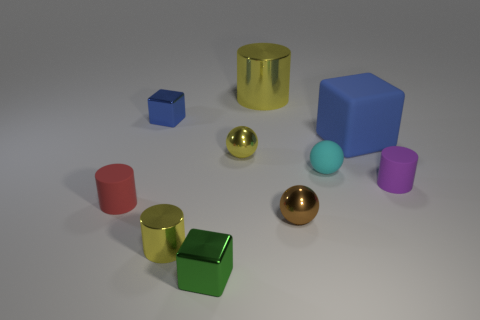Can you describe the composition of the shapes and how they are arranged? The composition features a collection of geometric shapes arranged without a rigid pattern. The shapes are scattered across a flat surface, with varying distances between them. Their organization seems random rather than conforming to a specific design, creating a relaxed assembly of forms.  If you had to guess, what material do these objects resemble? The materials the objects resemble include metallic surfaces for the spheres and some cylinders, suggestive of gold and bronze, as well as a more matte finish on the cubes and other cylinders which could be interpreted as plastic or painted wood based on their lack of reflectivity. 